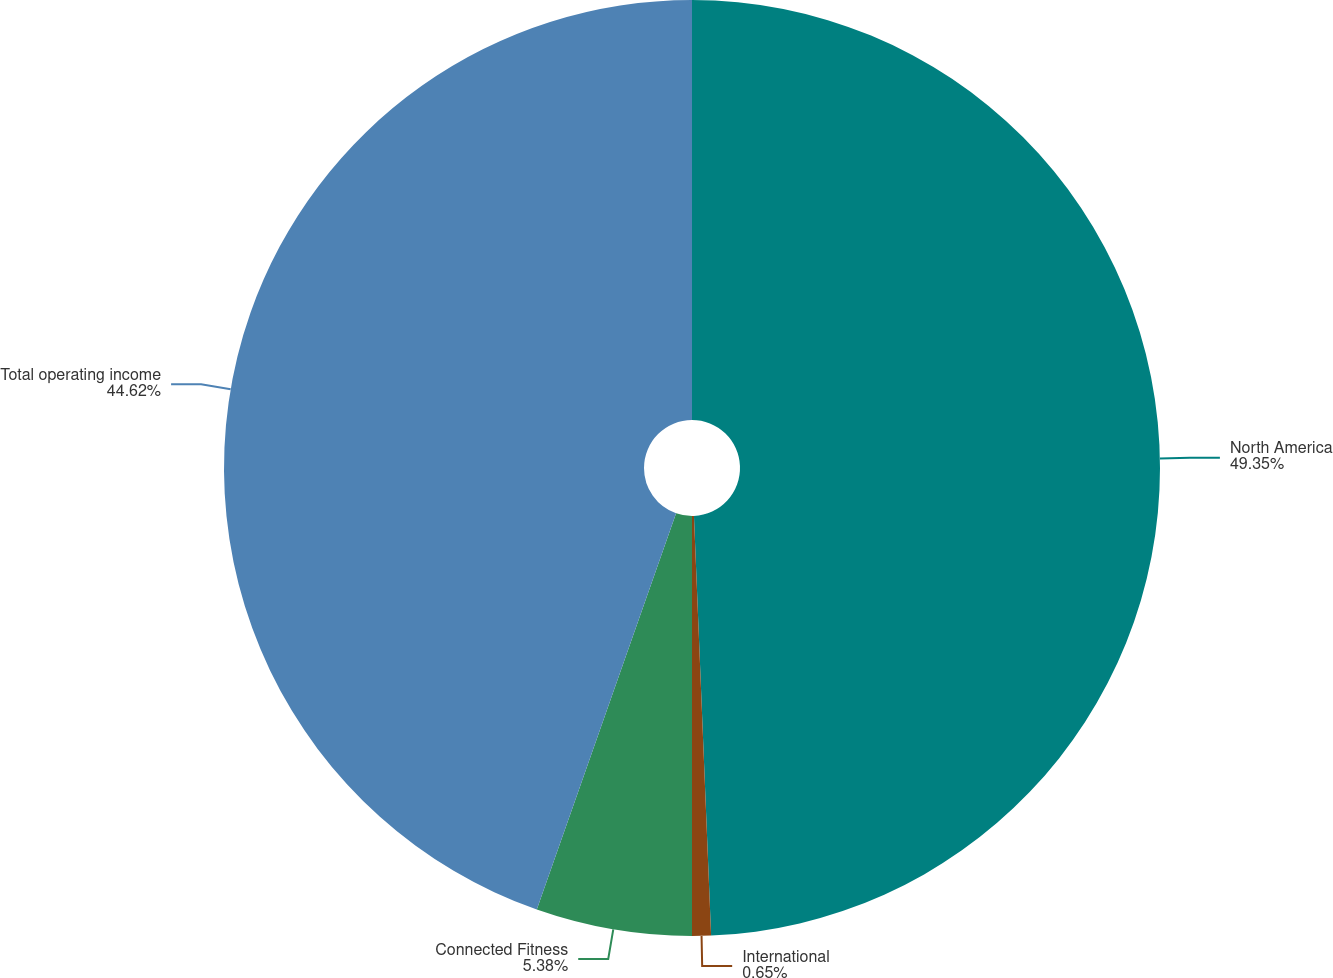<chart> <loc_0><loc_0><loc_500><loc_500><pie_chart><fcel>North America<fcel>International<fcel>Connected Fitness<fcel>Total operating income<nl><fcel>49.35%<fcel>0.65%<fcel>5.38%<fcel>44.62%<nl></chart> 